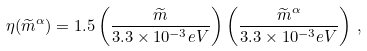Convert formula to latex. <formula><loc_0><loc_0><loc_500><loc_500>\eta ( \widetilde { m } ^ { \alpha } ) = 1 . 5 \left ( \frac { \widetilde { m } } { 3 . 3 \times 1 0 ^ { - 3 } e V } \right ) \left ( \frac { \widetilde { m } ^ { \alpha } } { 3 . 3 \times 1 0 ^ { - 3 } e V } \right ) \, ,</formula> 